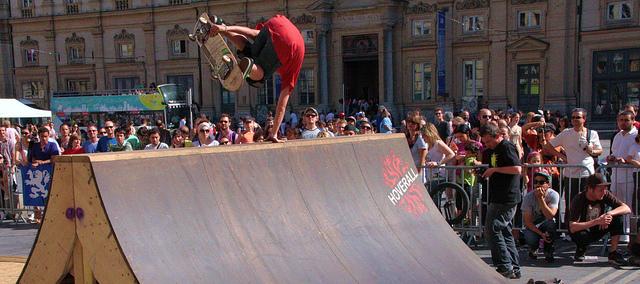What color is the skateboarder's shirt?
Keep it brief. Red. What sport is the person doing?
Be succinct. Skateboarding. Is this consider a sport?
Quick response, please. Yes. 